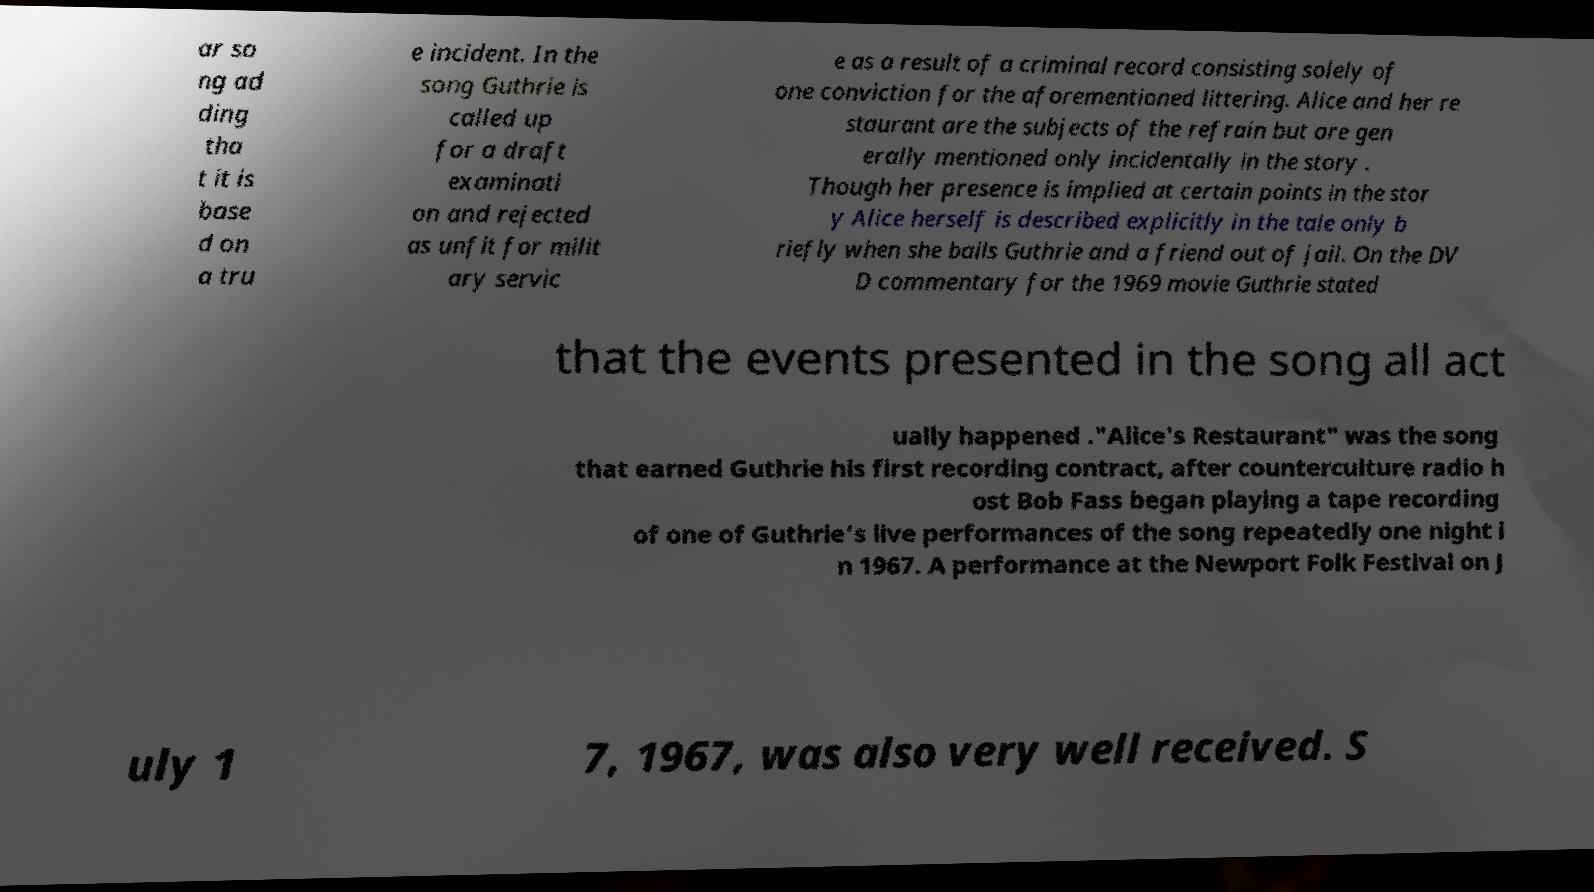Can you read and provide the text displayed in the image?This photo seems to have some interesting text. Can you extract and type it out for me? ar so ng ad ding tha t it is base d on a tru e incident. In the song Guthrie is called up for a draft examinati on and rejected as unfit for milit ary servic e as a result of a criminal record consisting solely of one conviction for the aforementioned littering. Alice and her re staurant are the subjects of the refrain but are gen erally mentioned only incidentally in the story . Though her presence is implied at certain points in the stor y Alice herself is described explicitly in the tale only b riefly when she bails Guthrie and a friend out of jail. On the DV D commentary for the 1969 movie Guthrie stated that the events presented in the song all act ually happened ."Alice's Restaurant" was the song that earned Guthrie his first recording contract, after counterculture radio h ost Bob Fass began playing a tape recording of one of Guthrie's live performances of the song repeatedly one night i n 1967. A performance at the Newport Folk Festival on J uly 1 7, 1967, was also very well received. S 